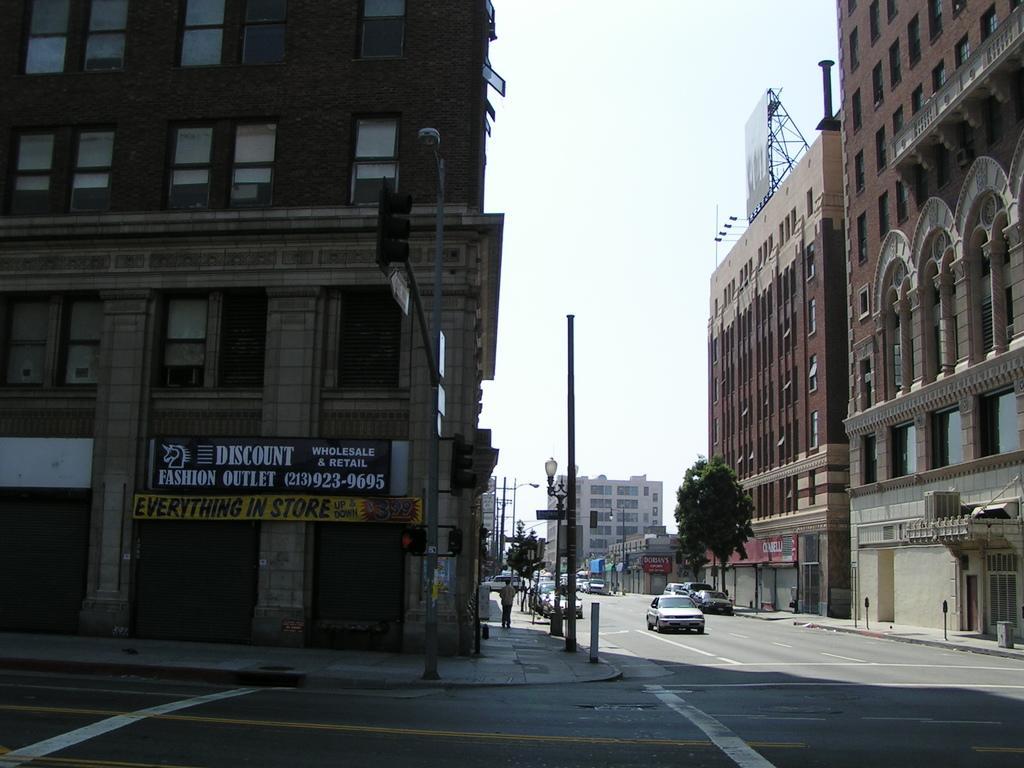In one or two sentences, can you explain what this image depicts? This picture is clicked outside the city. Here, we see the cars moving on the road. On either side of the road, there are buildings, trees and street lights. At the top of the picture, we see the sky. In the middle of the picture, we see a traffic signal and beside that, there is a board in black color with some text written on it. 